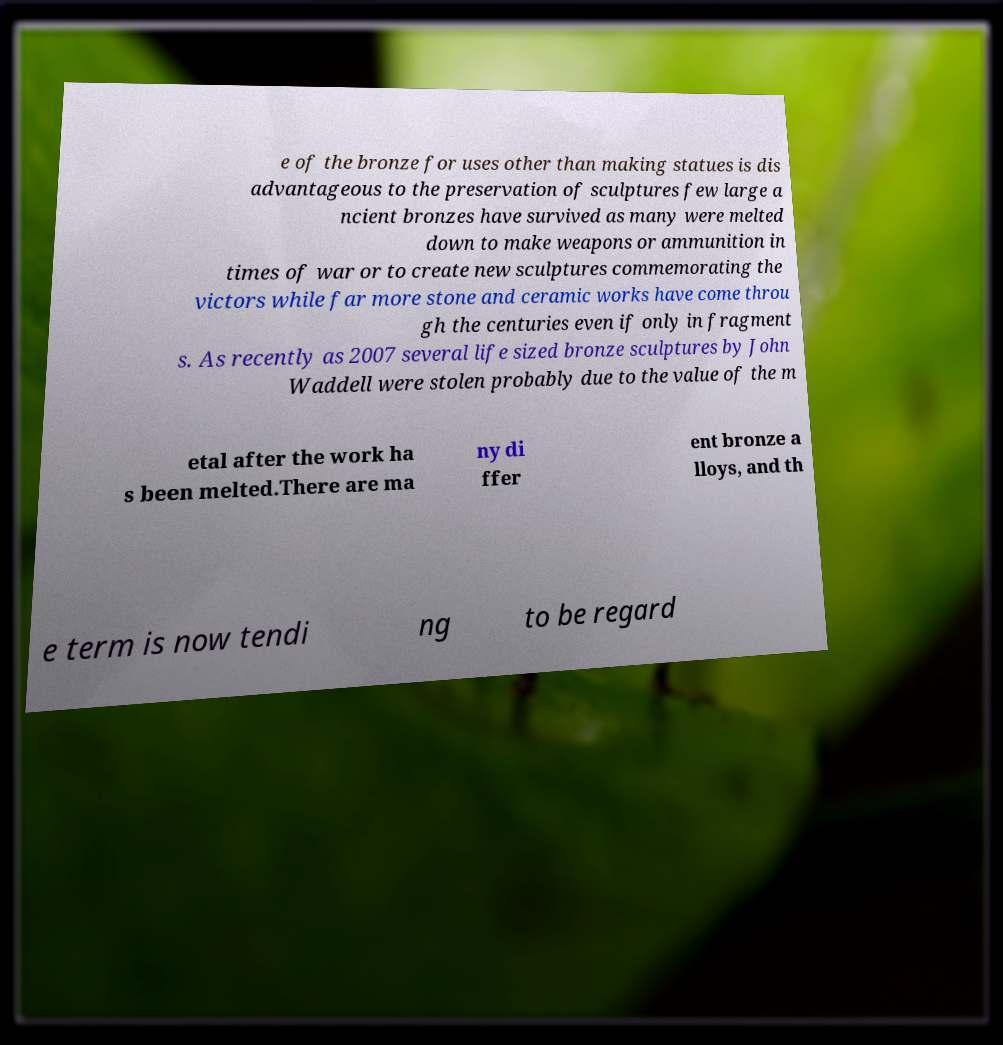For documentation purposes, I need the text within this image transcribed. Could you provide that? e of the bronze for uses other than making statues is dis advantageous to the preservation of sculptures few large a ncient bronzes have survived as many were melted down to make weapons or ammunition in times of war or to create new sculptures commemorating the victors while far more stone and ceramic works have come throu gh the centuries even if only in fragment s. As recently as 2007 several life sized bronze sculptures by John Waddell were stolen probably due to the value of the m etal after the work ha s been melted.There are ma ny di ffer ent bronze a lloys, and th e term is now tendi ng to be regard 